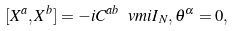Convert formula to latex. <formula><loc_0><loc_0><loc_500><loc_500>[ X ^ { a } , X ^ { b } ] = - i C ^ { a b } { \ v m i { I } } _ { N } , \theta ^ { \alpha } = 0 ,</formula> 